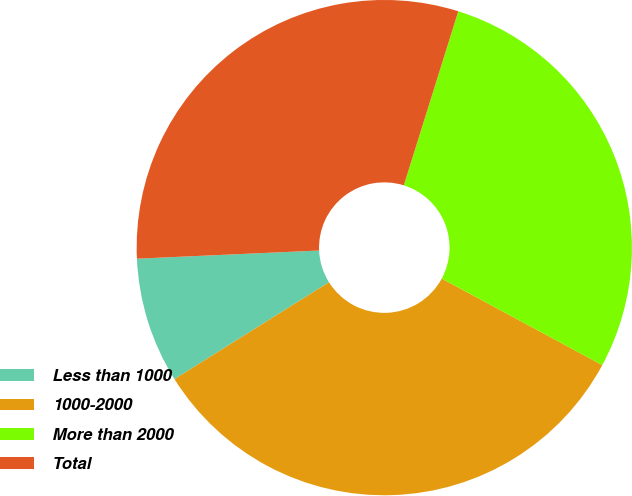<chart> <loc_0><loc_0><loc_500><loc_500><pie_chart><fcel>Less than 1000<fcel>1000-2000<fcel>More than 2000<fcel>Total<nl><fcel>8.2%<fcel>33.22%<fcel>28.04%<fcel>30.54%<nl></chart> 